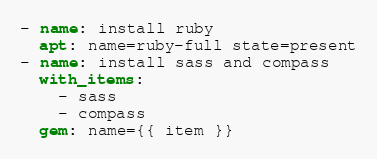<code> <loc_0><loc_0><loc_500><loc_500><_YAML_>- name: install ruby
  apt: name=ruby-full state=present
- name: install sass and compass
  with_items:
    - sass
    - compass
  gem: name={{ item }}
</code> 